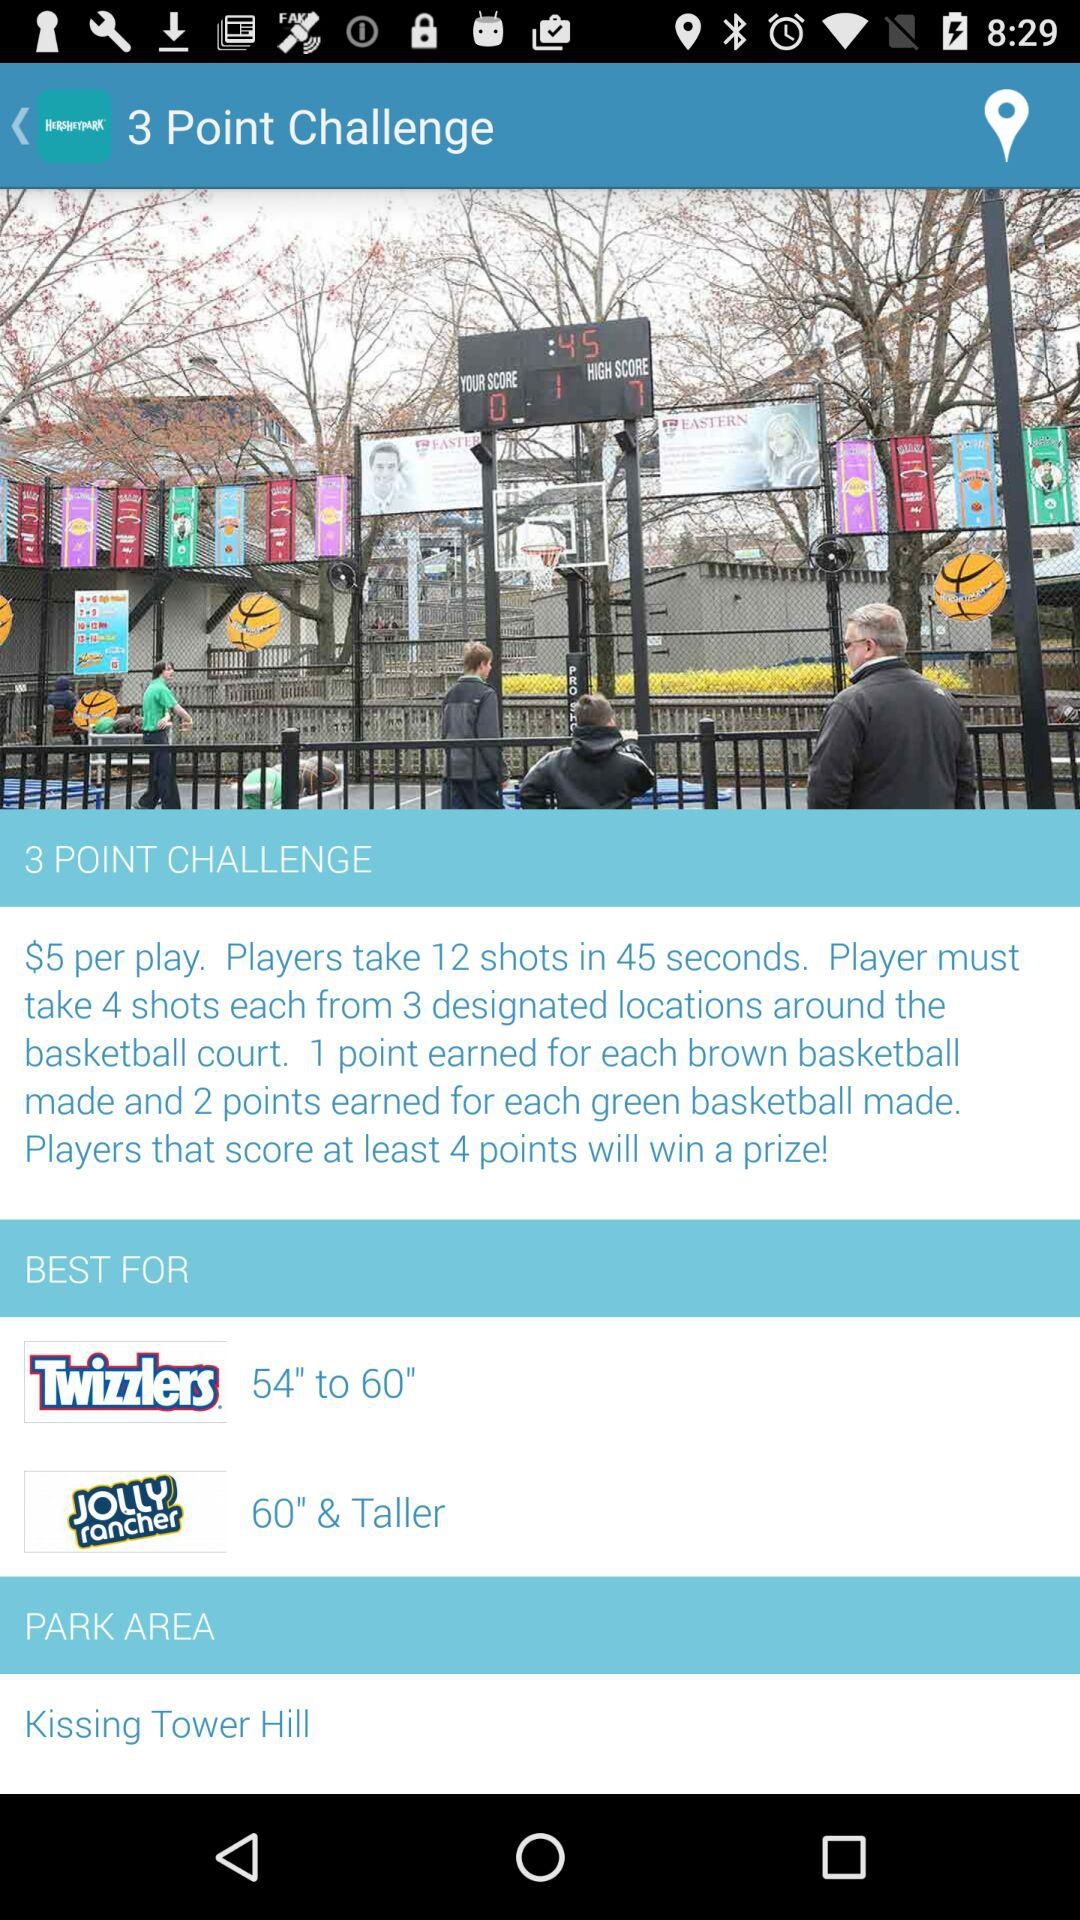How many more points do you earn for making a green basketball than a brown basketball?
Answer the question using a single word or phrase. 1 